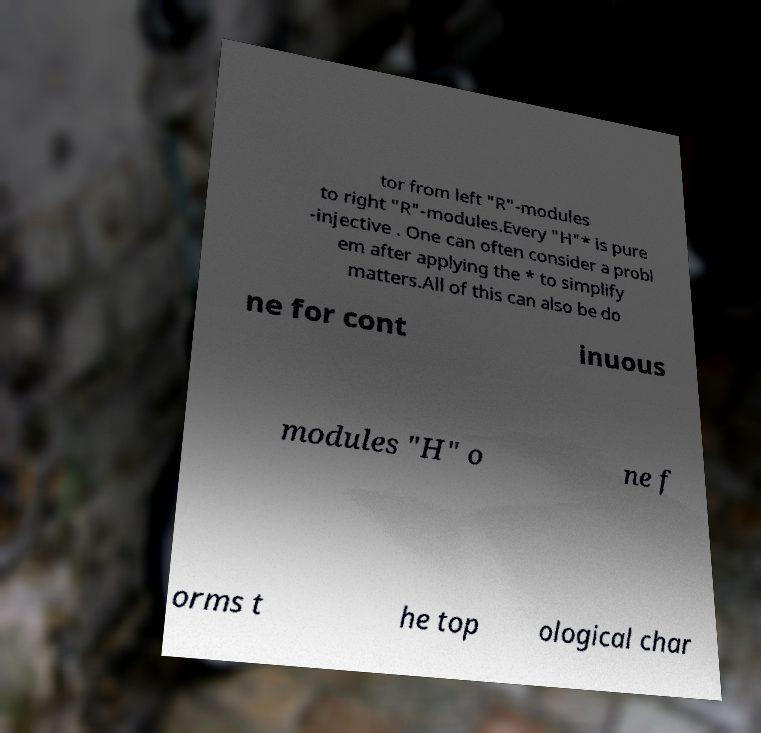Can you read and provide the text displayed in the image?This photo seems to have some interesting text. Can you extract and type it out for me? tor from left "R"-modules to right "R"-modules.Every "H"* is pure -injective . One can often consider a probl em after applying the * to simplify matters.All of this can also be do ne for cont inuous modules "H" o ne f orms t he top ological char 